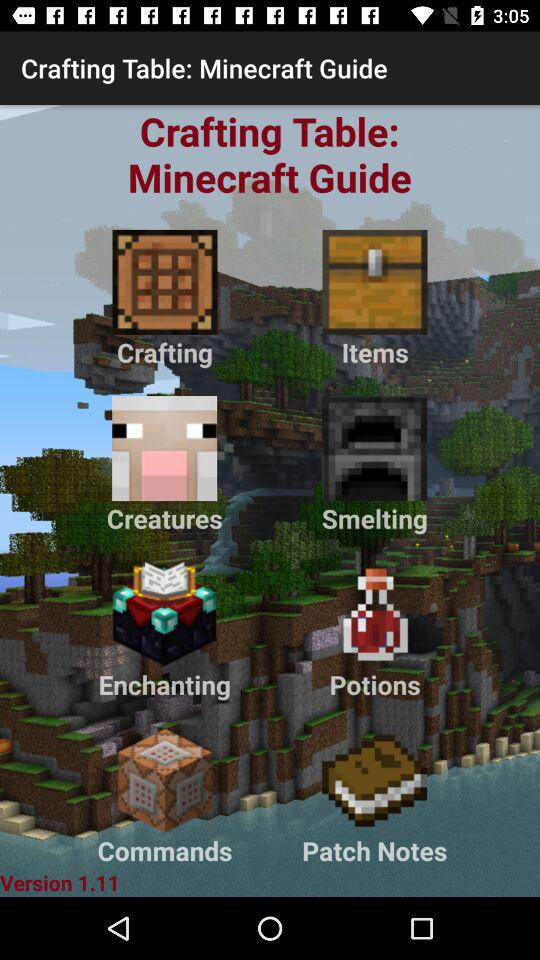What is the version? The version is 1.11. 